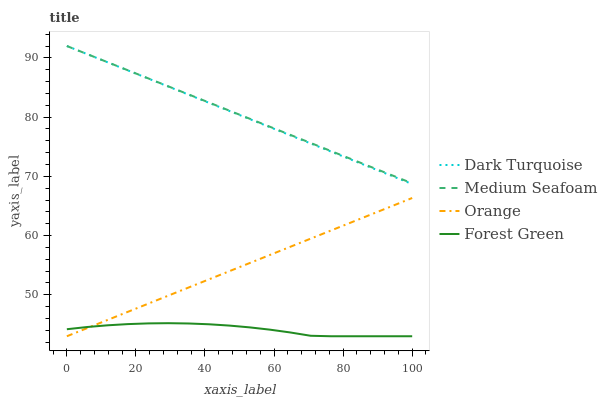Does Forest Green have the minimum area under the curve?
Answer yes or no. Yes. Does Medium Seafoam have the maximum area under the curve?
Answer yes or no. Yes. Does Dark Turquoise have the minimum area under the curve?
Answer yes or no. No. Does Dark Turquoise have the maximum area under the curve?
Answer yes or no. No. Is Orange the smoothest?
Answer yes or no. Yes. Is Forest Green the roughest?
Answer yes or no. Yes. Is Dark Turquoise the smoothest?
Answer yes or no. No. Is Dark Turquoise the roughest?
Answer yes or no. No. Does Orange have the lowest value?
Answer yes or no. Yes. Does Dark Turquoise have the lowest value?
Answer yes or no. No. Does Medium Seafoam have the highest value?
Answer yes or no. Yes. Does Forest Green have the highest value?
Answer yes or no. No. Is Forest Green less than Dark Turquoise?
Answer yes or no. Yes. Is Dark Turquoise greater than Forest Green?
Answer yes or no. Yes. Does Medium Seafoam intersect Dark Turquoise?
Answer yes or no. Yes. Is Medium Seafoam less than Dark Turquoise?
Answer yes or no. No. Is Medium Seafoam greater than Dark Turquoise?
Answer yes or no. No. Does Forest Green intersect Dark Turquoise?
Answer yes or no. No. 